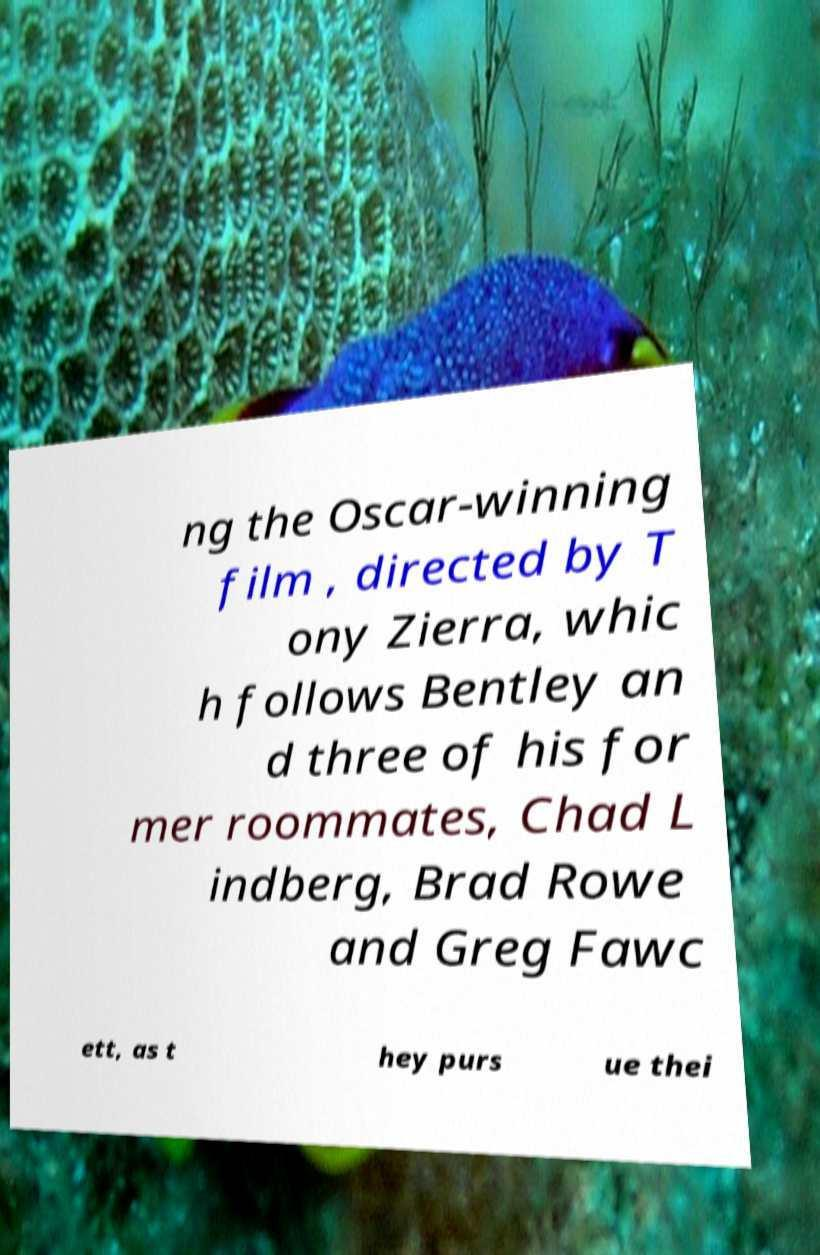There's text embedded in this image that I need extracted. Can you transcribe it verbatim? ng the Oscar-winning film , directed by T ony Zierra, whic h follows Bentley an d three of his for mer roommates, Chad L indberg, Brad Rowe and Greg Fawc ett, as t hey purs ue thei 